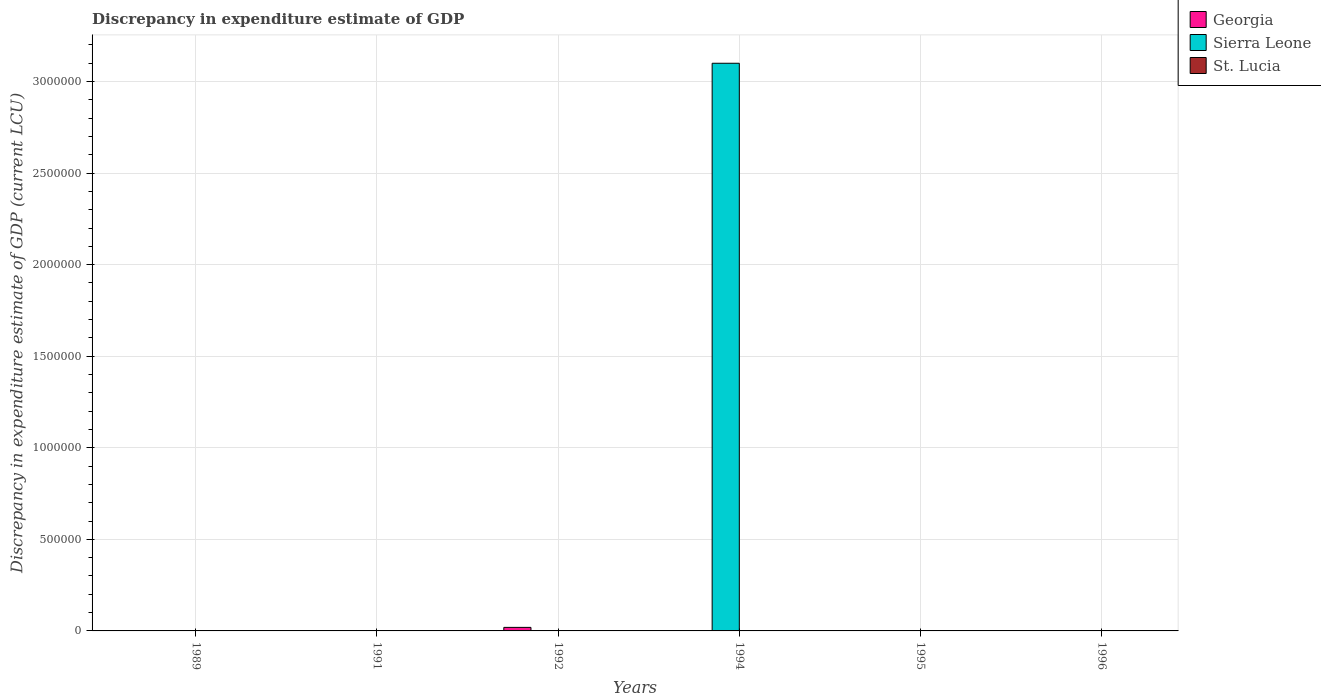How many different coloured bars are there?
Make the answer very short. 3. Are the number of bars per tick equal to the number of legend labels?
Give a very brief answer. No. How many bars are there on the 6th tick from the right?
Give a very brief answer. 2. What is the label of the 5th group of bars from the left?
Give a very brief answer. 1995. What is the discrepancy in expenditure estimate of GDP in Sierra Leone in 1995?
Provide a short and direct response. 0. Across all years, what is the maximum discrepancy in expenditure estimate of GDP in Georgia?
Keep it short and to the point. 1.93e+04. Across all years, what is the minimum discrepancy in expenditure estimate of GDP in St. Lucia?
Provide a short and direct response. 0. In which year was the discrepancy in expenditure estimate of GDP in St. Lucia maximum?
Make the answer very short. 1994. What is the total discrepancy in expenditure estimate of GDP in St. Lucia in the graph?
Offer a terse response. 1.7000000000000001e-7. What is the difference between the discrepancy in expenditure estimate of GDP in Georgia in 1992 and that in 1995?
Your answer should be very brief. 1.93e+04. What is the difference between the discrepancy in expenditure estimate of GDP in Sierra Leone in 1994 and the discrepancy in expenditure estimate of GDP in Georgia in 1995?
Ensure brevity in your answer.  3.10e+06. What is the average discrepancy in expenditure estimate of GDP in St. Lucia per year?
Offer a very short reply. 2.8333333333333336e-8. In how many years, is the discrepancy in expenditure estimate of GDP in Georgia greater than 500000 LCU?
Your answer should be very brief. 0. What is the ratio of the discrepancy in expenditure estimate of GDP in Georgia in 1991 to that in 1992?
Offer a very short reply. 0.01. What is the difference between the highest and the second highest discrepancy in expenditure estimate of GDP in Georgia?
Give a very brief answer. 1.92e+04. What is the difference between the highest and the lowest discrepancy in expenditure estimate of GDP in Sierra Leone?
Your answer should be very brief. 3.10e+06. Is the sum of the discrepancy in expenditure estimate of GDP in Georgia in 1991 and 1995 greater than the maximum discrepancy in expenditure estimate of GDP in Sierra Leone across all years?
Give a very brief answer. No. Does the graph contain any zero values?
Make the answer very short. Yes. How many legend labels are there?
Your answer should be very brief. 3. How are the legend labels stacked?
Keep it short and to the point. Vertical. What is the title of the graph?
Make the answer very short. Discrepancy in expenditure estimate of GDP. Does "Netherlands" appear as one of the legend labels in the graph?
Your answer should be compact. No. What is the label or title of the Y-axis?
Ensure brevity in your answer.  Discrepancy in expenditure estimate of GDP (current LCU). What is the Discrepancy in expenditure estimate of GDP (current LCU) in Sierra Leone in 1989?
Your response must be concise. 8e-6. What is the Discrepancy in expenditure estimate of GDP (current LCU) in Georgia in 1991?
Provide a succinct answer. 100. What is the Discrepancy in expenditure estimate of GDP (current LCU) of Sierra Leone in 1991?
Keep it short and to the point. 0. What is the Discrepancy in expenditure estimate of GDP (current LCU) of St. Lucia in 1991?
Provide a short and direct response. 0. What is the Discrepancy in expenditure estimate of GDP (current LCU) in Georgia in 1992?
Give a very brief answer. 1.93e+04. What is the Discrepancy in expenditure estimate of GDP (current LCU) of St. Lucia in 1992?
Offer a very short reply. 0. What is the Discrepancy in expenditure estimate of GDP (current LCU) of Georgia in 1994?
Keep it short and to the point. 0. What is the Discrepancy in expenditure estimate of GDP (current LCU) in Sierra Leone in 1994?
Your answer should be very brief. 3.10e+06. What is the Discrepancy in expenditure estimate of GDP (current LCU) of St. Lucia in 1994?
Offer a very short reply. 1.4e-7. What is the Discrepancy in expenditure estimate of GDP (current LCU) of Sierra Leone in 1995?
Offer a terse response. 0. What is the Discrepancy in expenditure estimate of GDP (current LCU) in St. Lucia in 1995?
Ensure brevity in your answer.  3e-8. Across all years, what is the maximum Discrepancy in expenditure estimate of GDP (current LCU) in Georgia?
Your response must be concise. 1.93e+04. Across all years, what is the maximum Discrepancy in expenditure estimate of GDP (current LCU) of Sierra Leone?
Offer a terse response. 3.10e+06. Across all years, what is the maximum Discrepancy in expenditure estimate of GDP (current LCU) in St. Lucia?
Offer a terse response. 1.4e-7. Across all years, what is the minimum Discrepancy in expenditure estimate of GDP (current LCU) of Sierra Leone?
Provide a short and direct response. 0. Across all years, what is the minimum Discrepancy in expenditure estimate of GDP (current LCU) in St. Lucia?
Provide a succinct answer. 0. What is the total Discrepancy in expenditure estimate of GDP (current LCU) of Georgia in the graph?
Provide a succinct answer. 1.95e+04. What is the total Discrepancy in expenditure estimate of GDP (current LCU) in Sierra Leone in the graph?
Give a very brief answer. 3.10e+06. What is the difference between the Discrepancy in expenditure estimate of GDP (current LCU) of Georgia in 1989 and that in 1992?
Offer a terse response. -1.92e+04. What is the difference between the Discrepancy in expenditure estimate of GDP (current LCU) of Sierra Leone in 1989 and that in 1994?
Keep it short and to the point. -3.10e+06. What is the difference between the Discrepancy in expenditure estimate of GDP (current LCU) of Georgia in 1991 and that in 1992?
Give a very brief answer. -1.92e+04. What is the difference between the Discrepancy in expenditure estimate of GDP (current LCU) of Georgia in 1991 and that in 1995?
Your response must be concise. 52. What is the difference between the Discrepancy in expenditure estimate of GDP (current LCU) in Georgia in 1992 and that in 1995?
Offer a terse response. 1.93e+04. What is the difference between the Discrepancy in expenditure estimate of GDP (current LCU) in St. Lucia in 1994 and that in 1995?
Your answer should be compact. 0. What is the difference between the Discrepancy in expenditure estimate of GDP (current LCU) of Georgia in 1989 and the Discrepancy in expenditure estimate of GDP (current LCU) of Sierra Leone in 1994?
Make the answer very short. -3.10e+06. What is the difference between the Discrepancy in expenditure estimate of GDP (current LCU) in Sierra Leone in 1989 and the Discrepancy in expenditure estimate of GDP (current LCU) in St. Lucia in 1995?
Offer a terse response. 0. What is the difference between the Discrepancy in expenditure estimate of GDP (current LCU) of Georgia in 1991 and the Discrepancy in expenditure estimate of GDP (current LCU) of Sierra Leone in 1994?
Provide a short and direct response. -3.10e+06. What is the difference between the Discrepancy in expenditure estimate of GDP (current LCU) in Georgia in 1991 and the Discrepancy in expenditure estimate of GDP (current LCU) in St. Lucia in 1995?
Provide a succinct answer. 100. What is the difference between the Discrepancy in expenditure estimate of GDP (current LCU) of Georgia in 1992 and the Discrepancy in expenditure estimate of GDP (current LCU) of Sierra Leone in 1994?
Give a very brief answer. -3.08e+06. What is the difference between the Discrepancy in expenditure estimate of GDP (current LCU) of Georgia in 1992 and the Discrepancy in expenditure estimate of GDP (current LCU) of St. Lucia in 1994?
Your response must be concise. 1.93e+04. What is the difference between the Discrepancy in expenditure estimate of GDP (current LCU) in Georgia in 1992 and the Discrepancy in expenditure estimate of GDP (current LCU) in St. Lucia in 1995?
Offer a very short reply. 1.93e+04. What is the difference between the Discrepancy in expenditure estimate of GDP (current LCU) in Sierra Leone in 1994 and the Discrepancy in expenditure estimate of GDP (current LCU) in St. Lucia in 1995?
Offer a terse response. 3.10e+06. What is the average Discrepancy in expenditure estimate of GDP (current LCU) of Georgia per year?
Your response must be concise. 3258. What is the average Discrepancy in expenditure estimate of GDP (current LCU) in Sierra Leone per year?
Offer a terse response. 5.17e+05. In the year 1989, what is the difference between the Discrepancy in expenditure estimate of GDP (current LCU) in Georgia and Discrepancy in expenditure estimate of GDP (current LCU) in Sierra Leone?
Offer a very short reply. 100. In the year 1994, what is the difference between the Discrepancy in expenditure estimate of GDP (current LCU) of Sierra Leone and Discrepancy in expenditure estimate of GDP (current LCU) of St. Lucia?
Give a very brief answer. 3.10e+06. What is the ratio of the Discrepancy in expenditure estimate of GDP (current LCU) in Georgia in 1989 to that in 1991?
Ensure brevity in your answer.  1. What is the ratio of the Discrepancy in expenditure estimate of GDP (current LCU) of Georgia in 1989 to that in 1992?
Give a very brief answer. 0.01. What is the ratio of the Discrepancy in expenditure estimate of GDP (current LCU) of Sierra Leone in 1989 to that in 1994?
Make the answer very short. 0. What is the ratio of the Discrepancy in expenditure estimate of GDP (current LCU) of Georgia in 1989 to that in 1995?
Your answer should be very brief. 2.08. What is the ratio of the Discrepancy in expenditure estimate of GDP (current LCU) of Georgia in 1991 to that in 1992?
Give a very brief answer. 0.01. What is the ratio of the Discrepancy in expenditure estimate of GDP (current LCU) of Georgia in 1991 to that in 1995?
Keep it short and to the point. 2.08. What is the ratio of the Discrepancy in expenditure estimate of GDP (current LCU) of Georgia in 1992 to that in 1995?
Keep it short and to the point. 402.08. What is the ratio of the Discrepancy in expenditure estimate of GDP (current LCU) in St. Lucia in 1994 to that in 1995?
Keep it short and to the point. 4.67. What is the difference between the highest and the second highest Discrepancy in expenditure estimate of GDP (current LCU) of Georgia?
Your answer should be very brief. 1.92e+04. What is the difference between the highest and the lowest Discrepancy in expenditure estimate of GDP (current LCU) of Georgia?
Offer a very short reply. 1.93e+04. What is the difference between the highest and the lowest Discrepancy in expenditure estimate of GDP (current LCU) in Sierra Leone?
Make the answer very short. 3.10e+06. What is the difference between the highest and the lowest Discrepancy in expenditure estimate of GDP (current LCU) of St. Lucia?
Offer a terse response. 0. 